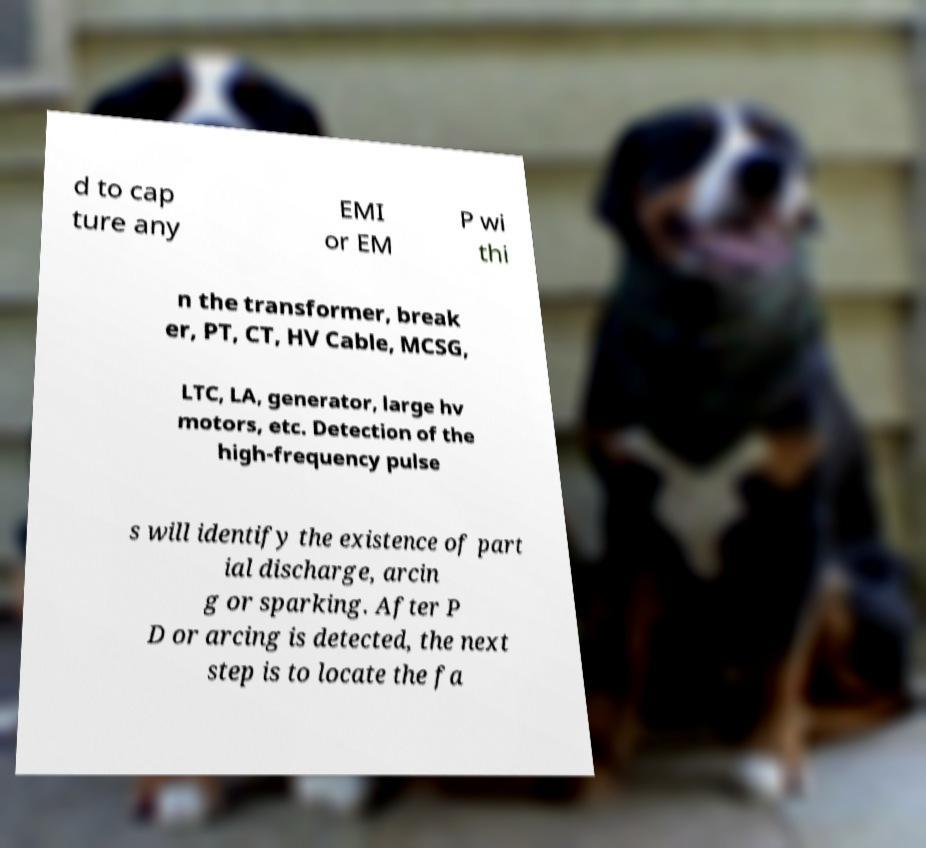Please read and relay the text visible in this image. What does it say? d to cap ture any EMI or EM P wi thi n the transformer, break er, PT, CT, HV Cable, MCSG, LTC, LA, generator, large hv motors, etc. Detection of the high-frequency pulse s will identify the existence of part ial discharge, arcin g or sparking. After P D or arcing is detected, the next step is to locate the fa 